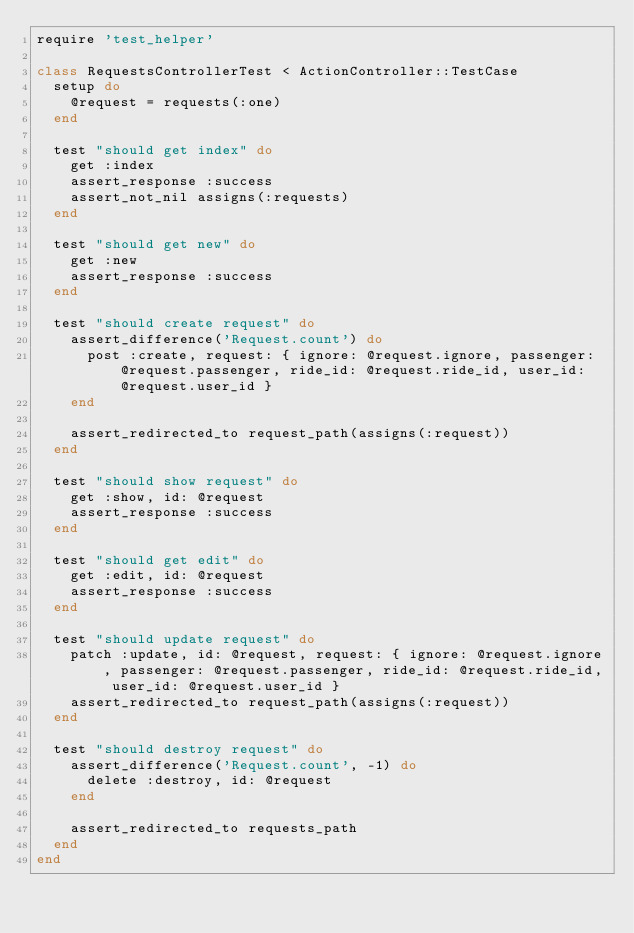<code> <loc_0><loc_0><loc_500><loc_500><_Ruby_>require 'test_helper'

class RequestsControllerTest < ActionController::TestCase
  setup do
    @request = requests(:one)
  end

  test "should get index" do
    get :index
    assert_response :success
    assert_not_nil assigns(:requests)
  end

  test "should get new" do
    get :new
    assert_response :success
  end

  test "should create request" do
    assert_difference('Request.count') do
      post :create, request: { ignore: @request.ignore, passenger: @request.passenger, ride_id: @request.ride_id, user_id: @request.user_id }
    end

    assert_redirected_to request_path(assigns(:request))
  end

  test "should show request" do
    get :show, id: @request
    assert_response :success
  end

  test "should get edit" do
    get :edit, id: @request
    assert_response :success
  end

  test "should update request" do
    patch :update, id: @request, request: { ignore: @request.ignore, passenger: @request.passenger, ride_id: @request.ride_id, user_id: @request.user_id }
    assert_redirected_to request_path(assigns(:request))
  end

  test "should destroy request" do
    assert_difference('Request.count', -1) do
      delete :destroy, id: @request
    end

    assert_redirected_to requests_path
  end
end
</code> 